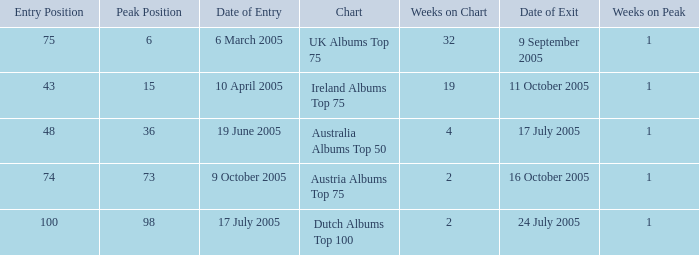What is the exit date for the Dutch Albums Top 100 Chart? 24 July 2005. Can you give me this table as a dict? {'header': ['Entry Position', 'Peak Position', 'Date of Entry', 'Chart', 'Weeks on Chart', 'Date of Exit', 'Weeks on Peak'], 'rows': [['75', '6', '6 March 2005', 'UK Albums Top 75', '32', '9 September 2005', '1'], ['43', '15', '10 April 2005', 'Ireland Albums Top 75', '19', '11 October 2005', '1'], ['48', '36', '19 June 2005', 'Australia Albums Top 50', '4', '17 July 2005', '1'], ['74', '73', '9 October 2005', 'Austria Albums Top 75', '2', '16 October 2005', '1'], ['100', '98', '17 July 2005', 'Dutch Albums Top 100', '2', '24 July 2005', '1']]} 